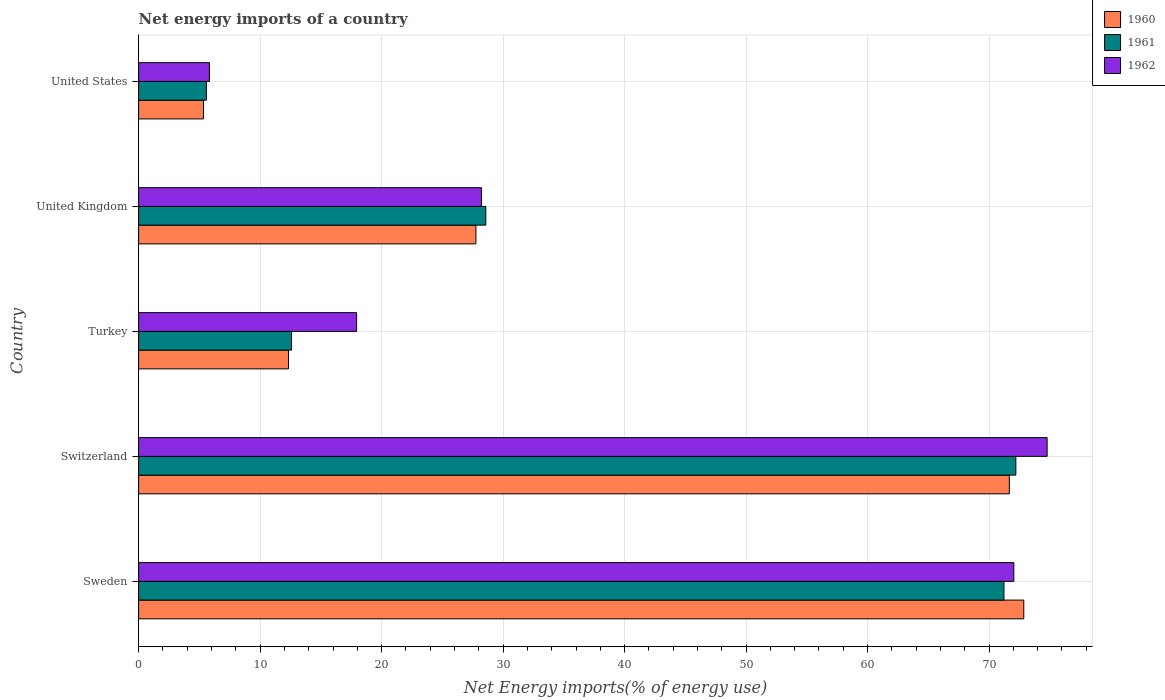How many different coloured bars are there?
Give a very brief answer. 3. Are the number of bars per tick equal to the number of legend labels?
Provide a short and direct response. Yes. Are the number of bars on each tick of the Y-axis equal?
Offer a terse response. Yes. How many bars are there on the 4th tick from the top?
Keep it short and to the point. 3. In how many cases, is the number of bars for a given country not equal to the number of legend labels?
Your response must be concise. 0. What is the net energy imports in 1960 in Switzerland?
Your answer should be compact. 71.67. Across all countries, what is the maximum net energy imports in 1961?
Ensure brevity in your answer.  72.21. Across all countries, what is the minimum net energy imports in 1962?
Your answer should be compact. 5.83. In which country was the net energy imports in 1961 maximum?
Ensure brevity in your answer.  Switzerland. What is the total net energy imports in 1961 in the graph?
Your answer should be very brief. 190.17. What is the difference between the net energy imports in 1961 in Turkey and that in United Kingdom?
Offer a terse response. -15.99. What is the difference between the net energy imports in 1961 in United States and the net energy imports in 1962 in Switzerland?
Provide a short and direct response. -69.2. What is the average net energy imports in 1960 per country?
Offer a terse response. 37.99. What is the difference between the net energy imports in 1962 and net energy imports in 1961 in Turkey?
Give a very brief answer. 5.36. In how many countries, is the net energy imports in 1962 greater than 66 %?
Ensure brevity in your answer.  2. What is the ratio of the net energy imports in 1960 in Sweden to that in Turkey?
Give a very brief answer. 5.91. Is the net energy imports in 1961 in United Kingdom less than that in United States?
Make the answer very short. No. Is the difference between the net energy imports in 1962 in Sweden and Turkey greater than the difference between the net energy imports in 1961 in Sweden and Turkey?
Make the answer very short. No. What is the difference between the highest and the second highest net energy imports in 1961?
Make the answer very short. 0.98. What is the difference between the highest and the lowest net energy imports in 1962?
Your answer should be very brief. 68.95. In how many countries, is the net energy imports in 1961 greater than the average net energy imports in 1961 taken over all countries?
Make the answer very short. 2. Is the sum of the net energy imports in 1961 in Sweden and United Kingdom greater than the maximum net energy imports in 1960 across all countries?
Make the answer very short. Yes. What does the 2nd bar from the top in United Kingdom represents?
Offer a very short reply. 1961. Is it the case that in every country, the sum of the net energy imports in 1962 and net energy imports in 1961 is greater than the net energy imports in 1960?
Keep it short and to the point. Yes. Are all the bars in the graph horizontal?
Ensure brevity in your answer.  Yes. How many countries are there in the graph?
Offer a terse response. 5. Are the values on the major ticks of X-axis written in scientific E-notation?
Provide a short and direct response. No. Does the graph contain any zero values?
Your answer should be very brief. No. Does the graph contain grids?
Keep it short and to the point. Yes. Where does the legend appear in the graph?
Keep it short and to the point. Top right. How are the legend labels stacked?
Ensure brevity in your answer.  Vertical. What is the title of the graph?
Offer a terse response. Net energy imports of a country. Does "1989" appear as one of the legend labels in the graph?
Provide a short and direct response. No. What is the label or title of the X-axis?
Ensure brevity in your answer.  Net Energy imports(% of energy use). What is the Net Energy imports(% of energy use) in 1960 in Sweden?
Provide a succinct answer. 72.86. What is the Net Energy imports(% of energy use) in 1961 in Sweden?
Keep it short and to the point. 71.22. What is the Net Energy imports(% of energy use) in 1962 in Sweden?
Your answer should be very brief. 72.04. What is the Net Energy imports(% of energy use) of 1960 in Switzerland?
Provide a succinct answer. 71.67. What is the Net Energy imports(% of energy use) of 1961 in Switzerland?
Offer a very short reply. 72.21. What is the Net Energy imports(% of energy use) of 1962 in Switzerland?
Your answer should be very brief. 74.78. What is the Net Energy imports(% of energy use) of 1960 in Turkey?
Give a very brief answer. 12.34. What is the Net Energy imports(% of energy use) in 1961 in Turkey?
Keep it short and to the point. 12.59. What is the Net Energy imports(% of energy use) of 1962 in Turkey?
Your response must be concise. 17.94. What is the Net Energy imports(% of energy use) of 1960 in United Kingdom?
Offer a very short reply. 27.76. What is the Net Energy imports(% of energy use) in 1961 in United Kingdom?
Give a very brief answer. 28.58. What is the Net Energy imports(% of energy use) in 1962 in United Kingdom?
Your answer should be very brief. 28.22. What is the Net Energy imports(% of energy use) in 1960 in United States?
Your answer should be very brief. 5.34. What is the Net Energy imports(% of energy use) in 1961 in United States?
Offer a very short reply. 5.58. What is the Net Energy imports(% of energy use) in 1962 in United States?
Ensure brevity in your answer.  5.83. Across all countries, what is the maximum Net Energy imports(% of energy use) in 1960?
Your answer should be compact. 72.86. Across all countries, what is the maximum Net Energy imports(% of energy use) in 1961?
Keep it short and to the point. 72.21. Across all countries, what is the maximum Net Energy imports(% of energy use) in 1962?
Keep it short and to the point. 74.78. Across all countries, what is the minimum Net Energy imports(% of energy use) of 1960?
Provide a succinct answer. 5.34. Across all countries, what is the minimum Net Energy imports(% of energy use) in 1961?
Your response must be concise. 5.58. Across all countries, what is the minimum Net Energy imports(% of energy use) of 1962?
Ensure brevity in your answer.  5.83. What is the total Net Energy imports(% of energy use) of 1960 in the graph?
Offer a terse response. 189.96. What is the total Net Energy imports(% of energy use) of 1961 in the graph?
Keep it short and to the point. 190.17. What is the total Net Energy imports(% of energy use) of 1962 in the graph?
Give a very brief answer. 198.8. What is the difference between the Net Energy imports(% of energy use) of 1960 in Sweden and that in Switzerland?
Make the answer very short. 1.19. What is the difference between the Net Energy imports(% of energy use) in 1961 in Sweden and that in Switzerland?
Offer a very short reply. -0.98. What is the difference between the Net Energy imports(% of energy use) of 1962 in Sweden and that in Switzerland?
Give a very brief answer. -2.74. What is the difference between the Net Energy imports(% of energy use) in 1960 in Sweden and that in Turkey?
Give a very brief answer. 60.52. What is the difference between the Net Energy imports(% of energy use) in 1961 in Sweden and that in Turkey?
Ensure brevity in your answer.  58.64. What is the difference between the Net Energy imports(% of energy use) of 1962 in Sweden and that in Turkey?
Provide a short and direct response. 54.1. What is the difference between the Net Energy imports(% of energy use) of 1960 in Sweden and that in United Kingdom?
Provide a succinct answer. 45.1. What is the difference between the Net Energy imports(% of energy use) of 1961 in Sweden and that in United Kingdom?
Your answer should be compact. 42.65. What is the difference between the Net Energy imports(% of energy use) of 1962 in Sweden and that in United Kingdom?
Offer a very short reply. 43.82. What is the difference between the Net Energy imports(% of energy use) of 1960 in Sweden and that in United States?
Ensure brevity in your answer.  67.52. What is the difference between the Net Energy imports(% of energy use) in 1961 in Sweden and that in United States?
Your answer should be compact. 65.65. What is the difference between the Net Energy imports(% of energy use) of 1962 in Sweden and that in United States?
Ensure brevity in your answer.  66.21. What is the difference between the Net Energy imports(% of energy use) in 1960 in Switzerland and that in Turkey?
Make the answer very short. 59.33. What is the difference between the Net Energy imports(% of energy use) of 1961 in Switzerland and that in Turkey?
Your answer should be compact. 59.62. What is the difference between the Net Energy imports(% of energy use) in 1962 in Switzerland and that in Turkey?
Your response must be concise. 56.84. What is the difference between the Net Energy imports(% of energy use) of 1960 in Switzerland and that in United Kingdom?
Make the answer very short. 43.91. What is the difference between the Net Energy imports(% of energy use) in 1961 in Switzerland and that in United Kingdom?
Your answer should be very brief. 43.63. What is the difference between the Net Energy imports(% of energy use) in 1962 in Switzerland and that in United Kingdom?
Give a very brief answer. 46.56. What is the difference between the Net Energy imports(% of energy use) in 1960 in Switzerland and that in United States?
Ensure brevity in your answer.  66.33. What is the difference between the Net Energy imports(% of energy use) of 1961 in Switzerland and that in United States?
Your answer should be compact. 66.63. What is the difference between the Net Energy imports(% of energy use) in 1962 in Switzerland and that in United States?
Your answer should be compact. 68.95. What is the difference between the Net Energy imports(% of energy use) in 1960 in Turkey and that in United Kingdom?
Make the answer very short. -15.43. What is the difference between the Net Energy imports(% of energy use) of 1961 in Turkey and that in United Kingdom?
Offer a very short reply. -15.99. What is the difference between the Net Energy imports(% of energy use) of 1962 in Turkey and that in United Kingdom?
Offer a terse response. -10.27. What is the difference between the Net Energy imports(% of energy use) in 1960 in Turkey and that in United States?
Your answer should be very brief. 6.99. What is the difference between the Net Energy imports(% of energy use) in 1961 in Turkey and that in United States?
Make the answer very short. 7.01. What is the difference between the Net Energy imports(% of energy use) in 1962 in Turkey and that in United States?
Give a very brief answer. 12.12. What is the difference between the Net Energy imports(% of energy use) of 1960 in United Kingdom and that in United States?
Make the answer very short. 22.42. What is the difference between the Net Energy imports(% of energy use) in 1961 in United Kingdom and that in United States?
Your answer should be very brief. 23. What is the difference between the Net Energy imports(% of energy use) in 1962 in United Kingdom and that in United States?
Your answer should be very brief. 22.39. What is the difference between the Net Energy imports(% of energy use) of 1960 in Sweden and the Net Energy imports(% of energy use) of 1961 in Switzerland?
Your answer should be compact. 0.65. What is the difference between the Net Energy imports(% of energy use) in 1960 in Sweden and the Net Energy imports(% of energy use) in 1962 in Switzerland?
Give a very brief answer. -1.92. What is the difference between the Net Energy imports(% of energy use) in 1961 in Sweden and the Net Energy imports(% of energy use) in 1962 in Switzerland?
Give a very brief answer. -3.56. What is the difference between the Net Energy imports(% of energy use) of 1960 in Sweden and the Net Energy imports(% of energy use) of 1961 in Turkey?
Your answer should be very brief. 60.27. What is the difference between the Net Energy imports(% of energy use) of 1960 in Sweden and the Net Energy imports(% of energy use) of 1962 in Turkey?
Your response must be concise. 54.92. What is the difference between the Net Energy imports(% of energy use) of 1961 in Sweden and the Net Energy imports(% of energy use) of 1962 in Turkey?
Offer a very short reply. 53.28. What is the difference between the Net Energy imports(% of energy use) in 1960 in Sweden and the Net Energy imports(% of energy use) in 1961 in United Kingdom?
Offer a very short reply. 44.28. What is the difference between the Net Energy imports(% of energy use) of 1960 in Sweden and the Net Energy imports(% of energy use) of 1962 in United Kingdom?
Keep it short and to the point. 44.64. What is the difference between the Net Energy imports(% of energy use) of 1961 in Sweden and the Net Energy imports(% of energy use) of 1962 in United Kingdom?
Provide a succinct answer. 43.01. What is the difference between the Net Energy imports(% of energy use) in 1960 in Sweden and the Net Energy imports(% of energy use) in 1961 in United States?
Provide a succinct answer. 67.28. What is the difference between the Net Energy imports(% of energy use) of 1960 in Sweden and the Net Energy imports(% of energy use) of 1962 in United States?
Ensure brevity in your answer.  67.03. What is the difference between the Net Energy imports(% of energy use) of 1961 in Sweden and the Net Energy imports(% of energy use) of 1962 in United States?
Provide a short and direct response. 65.4. What is the difference between the Net Energy imports(% of energy use) in 1960 in Switzerland and the Net Energy imports(% of energy use) in 1961 in Turkey?
Provide a succinct answer. 59.08. What is the difference between the Net Energy imports(% of energy use) in 1960 in Switzerland and the Net Energy imports(% of energy use) in 1962 in Turkey?
Provide a short and direct response. 53.73. What is the difference between the Net Energy imports(% of energy use) of 1961 in Switzerland and the Net Energy imports(% of energy use) of 1962 in Turkey?
Offer a terse response. 54.26. What is the difference between the Net Energy imports(% of energy use) of 1960 in Switzerland and the Net Energy imports(% of energy use) of 1961 in United Kingdom?
Your response must be concise. 43.09. What is the difference between the Net Energy imports(% of energy use) in 1960 in Switzerland and the Net Energy imports(% of energy use) in 1962 in United Kingdom?
Your answer should be compact. 43.45. What is the difference between the Net Energy imports(% of energy use) of 1961 in Switzerland and the Net Energy imports(% of energy use) of 1962 in United Kingdom?
Offer a very short reply. 43.99. What is the difference between the Net Energy imports(% of energy use) in 1960 in Switzerland and the Net Energy imports(% of energy use) in 1961 in United States?
Make the answer very short. 66.09. What is the difference between the Net Energy imports(% of energy use) in 1960 in Switzerland and the Net Energy imports(% of energy use) in 1962 in United States?
Offer a terse response. 65.84. What is the difference between the Net Energy imports(% of energy use) in 1961 in Switzerland and the Net Energy imports(% of energy use) in 1962 in United States?
Provide a short and direct response. 66.38. What is the difference between the Net Energy imports(% of energy use) of 1960 in Turkey and the Net Energy imports(% of energy use) of 1961 in United Kingdom?
Give a very brief answer. -16.24. What is the difference between the Net Energy imports(% of energy use) in 1960 in Turkey and the Net Energy imports(% of energy use) in 1962 in United Kingdom?
Make the answer very short. -15.88. What is the difference between the Net Energy imports(% of energy use) in 1961 in Turkey and the Net Energy imports(% of energy use) in 1962 in United Kingdom?
Give a very brief answer. -15.63. What is the difference between the Net Energy imports(% of energy use) in 1960 in Turkey and the Net Energy imports(% of energy use) in 1961 in United States?
Provide a short and direct response. 6.76. What is the difference between the Net Energy imports(% of energy use) of 1960 in Turkey and the Net Energy imports(% of energy use) of 1962 in United States?
Give a very brief answer. 6.51. What is the difference between the Net Energy imports(% of energy use) in 1961 in Turkey and the Net Energy imports(% of energy use) in 1962 in United States?
Give a very brief answer. 6.76. What is the difference between the Net Energy imports(% of energy use) in 1960 in United Kingdom and the Net Energy imports(% of energy use) in 1961 in United States?
Offer a terse response. 22.18. What is the difference between the Net Energy imports(% of energy use) in 1960 in United Kingdom and the Net Energy imports(% of energy use) in 1962 in United States?
Keep it short and to the point. 21.94. What is the difference between the Net Energy imports(% of energy use) of 1961 in United Kingdom and the Net Energy imports(% of energy use) of 1962 in United States?
Keep it short and to the point. 22.75. What is the average Net Energy imports(% of energy use) in 1960 per country?
Ensure brevity in your answer.  37.99. What is the average Net Energy imports(% of energy use) in 1961 per country?
Give a very brief answer. 38.03. What is the average Net Energy imports(% of energy use) in 1962 per country?
Offer a very short reply. 39.76. What is the difference between the Net Energy imports(% of energy use) in 1960 and Net Energy imports(% of energy use) in 1961 in Sweden?
Give a very brief answer. 1.63. What is the difference between the Net Energy imports(% of energy use) in 1960 and Net Energy imports(% of energy use) in 1962 in Sweden?
Your response must be concise. 0.82. What is the difference between the Net Energy imports(% of energy use) of 1961 and Net Energy imports(% of energy use) of 1962 in Sweden?
Provide a short and direct response. -0.81. What is the difference between the Net Energy imports(% of energy use) in 1960 and Net Energy imports(% of energy use) in 1961 in Switzerland?
Make the answer very short. -0.54. What is the difference between the Net Energy imports(% of energy use) of 1960 and Net Energy imports(% of energy use) of 1962 in Switzerland?
Offer a very short reply. -3.11. What is the difference between the Net Energy imports(% of energy use) in 1961 and Net Energy imports(% of energy use) in 1962 in Switzerland?
Provide a short and direct response. -2.57. What is the difference between the Net Energy imports(% of energy use) in 1960 and Net Energy imports(% of energy use) in 1961 in Turkey?
Your answer should be very brief. -0.25. What is the difference between the Net Energy imports(% of energy use) of 1960 and Net Energy imports(% of energy use) of 1962 in Turkey?
Your response must be concise. -5.61. What is the difference between the Net Energy imports(% of energy use) of 1961 and Net Energy imports(% of energy use) of 1962 in Turkey?
Your response must be concise. -5.36. What is the difference between the Net Energy imports(% of energy use) of 1960 and Net Energy imports(% of energy use) of 1961 in United Kingdom?
Offer a very short reply. -0.81. What is the difference between the Net Energy imports(% of energy use) in 1960 and Net Energy imports(% of energy use) in 1962 in United Kingdom?
Provide a succinct answer. -0.45. What is the difference between the Net Energy imports(% of energy use) in 1961 and Net Energy imports(% of energy use) in 1962 in United Kingdom?
Offer a terse response. 0.36. What is the difference between the Net Energy imports(% of energy use) of 1960 and Net Energy imports(% of energy use) of 1961 in United States?
Your answer should be very brief. -0.24. What is the difference between the Net Energy imports(% of energy use) in 1960 and Net Energy imports(% of energy use) in 1962 in United States?
Ensure brevity in your answer.  -0.49. What is the difference between the Net Energy imports(% of energy use) of 1961 and Net Energy imports(% of energy use) of 1962 in United States?
Offer a terse response. -0.25. What is the ratio of the Net Energy imports(% of energy use) in 1960 in Sweden to that in Switzerland?
Your answer should be compact. 1.02. What is the ratio of the Net Energy imports(% of energy use) of 1961 in Sweden to that in Switzerland?
Provide a succinct answer. 0.99. What is the ratio of the Net Energy imports(% of energy use) in 1962 in Sweden to that in Switzerland?
Your answer should be compact. 0.96. What is the ratio of the Net Energy imports(% of energy use) in 1960 in Sweden to that in Turkey?
Provide a short and direct response. 5.91. What is the ratio of the Net Energy imports(% of energy use) in 1961 in Sweden to that in Turkey?
Your answer should be compact. 5.66. What is the ratio of the Net Energy imports(% of energy use) in 1962 in Sweden to that in Turkey?
Your answer should be very brief. 4.02. What is the ratio of the Net Energy imports(% of energy use) of 1960 in Sweden to that in United Kingdom?
Make the answer very short. 2.62. What is the ratio of the Net Energy imports(% of energy use) of 1961 in Sweden to that in United Kingdom?
Provide a short and direct response. 2.49. What is the ratio of the Net Energy imports(% of energy use) of 1962 in Sweden to that in United Kingdom?
Provide a succinct answer. 2.55. What is the ratio of the Net Energy imports(% of energy use) in 1960 in Sweden to that in United States?
Give a very brief answer. 13.64. What is the ratio of the Net Energy imports(% of energy use) in 1961 in Sweden to that in United States?
Offer a very short reply. 12.77. What is the ratio of the Net Energy imports(% of energy use) of 1962 in Sweden to that in United States?
Your answer should be compact. 12.37. What is the ratio of the Net Energy imports(% of energy use) in 1960 in Switzerland to that in Turkey?
Provide a succinct answer. 5.81. What is the ratio of the Net Energy imports(% of energy use) of 1961 in Switzerland to that in Turkey?
Give a very brief answer. 5.74. What is the ratio of the Net Energy imports(% of energy use) of 1962 in Switzerland to that in Turkey?
Your answer should be compact. 4.17. What is the ratio of the Net Energy imports(% of energy use) of 1960 in Switzerland to that in United Kingdom?
Your answer should be very brief. 2.58. What is the ratio of the Net Energy imports(% of energy use) in 1961 in Switzerland to that in United Kingdom?
Give a very brief answer. 2.53. What is the ratio of the Net Energy imports(% of energy use) in 1962 in Switzerland to that in United Kingdom?
Your answer should be very brief. 2.65. What is the ratio of the Net Energy imports(% of energy use) in 1960 in Switzerland to that in United States?
Your answer should be compact. 13.42. What is the ratio of the Net Energy imports(% of energy use) in 1961 in Switzerland to that in United States?
Offer a very short reply. 12.94. What is the ratio of the Net Energy imports(% of energy use) of 1962 in Switzerland to that in United States?
Your response must be concise. 12.84. What is the ratio of the Net Energy imports(% of energy use) in 1960 in Turkey to that in United Kingdom?
Your answer should be compact. 0.44. What is the ratio of the Net Energy imports(% of energy use) in 1961 in Turkey to that in United Kingdom?
Give a very brief answer. 0.44. What is the ratio of the Net Energy imports(% of energy use) in 1962 in Turkey to that in United Kingdom?
Give a very brief answer. 0.64. What is the ratio of the Net Energy imports(% of energy use) of 1960 in Turkey to that in United States?
Ensure brevity in your answer.  2.31. What is the ratio of the Net Energy imports(% of energy use) of 1961 in Turkey to that in United States?
Your answer should be compact. 2.26. What is the ratio of the Net Energy imports(% of energy use) of 1962 in Turkey to that in United States?
Your answer should be very brief. 3.08. What is the ratio of the Net Energy imports(% of energy use) of 1960 in United Kingdom to that in United States?
Ensure brevity in your answer.  5.2. What is the ratio of the Net Energy imports(% of energy use) in 1961 in United Kingdom to that in United States?
Your answer should be very brief. 5.12. What is the ratio of the Net Energy imports(% of energy use) of 1962 in United Kingdom to that in United States?
Your answer should be very brief. 4.84. What is the difference between the highest and the second highest Net Energy imports(% of energy use) in 1960?
Ensure brevity in your answer.  1.19. What is the difference between the highest and the second highest Net Energy imports(% of energy use) in 1961?
Your answer should be very brief. 0.98. What is the difference between the highest and the second highest Net Energy imports(% of energy use) of 1962?
Your answer should be compact. 2.74. What is the difference between the highest and the lowest Net Energy imports(% of energy use) of 1960?
Make the answer very short. 67.52. What is the difference between the highest and the lowest Net Energy imports(% of energy use) in 1961?
Provide a short and direct response. 66.63. What is the difference between the highest and the lowest Net Energy imports(% of energy use) in 1962?
Your answer should be compact. 68.95. 